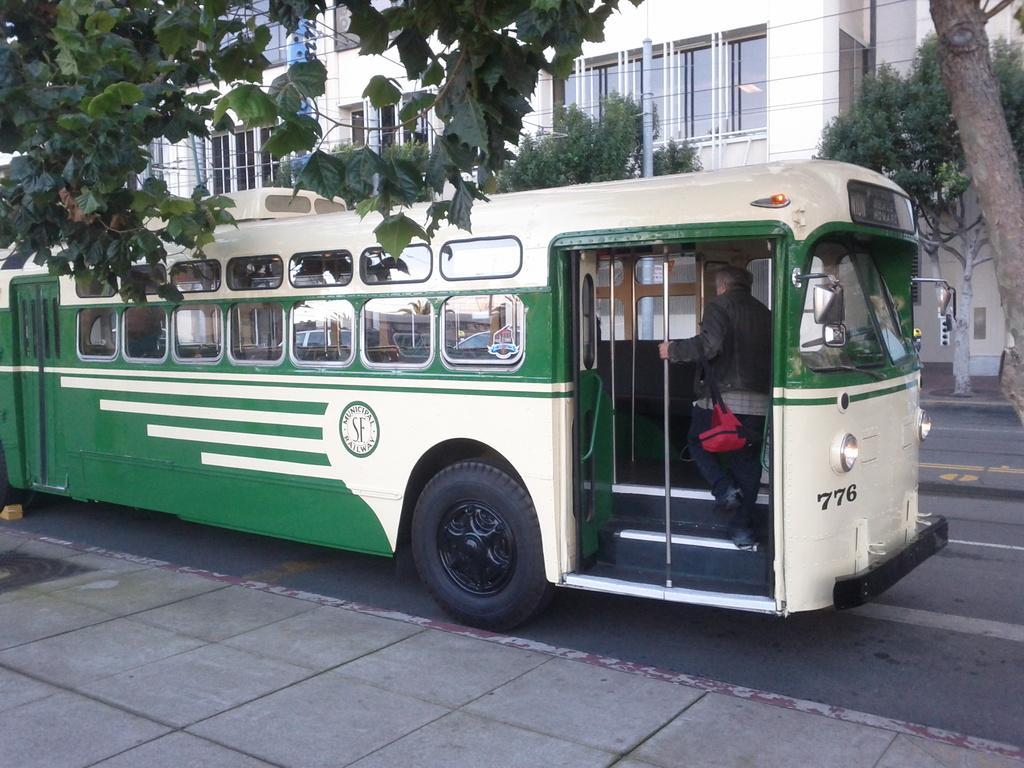In one or two sentences, can you explain what this image depicts? In this image I see a bus which is of cream and green in color and I see a man over here and I see few rods and I see the steps over here and I see 3 numbers over here and I see the road and I see number of trees. In the background I see a building. 